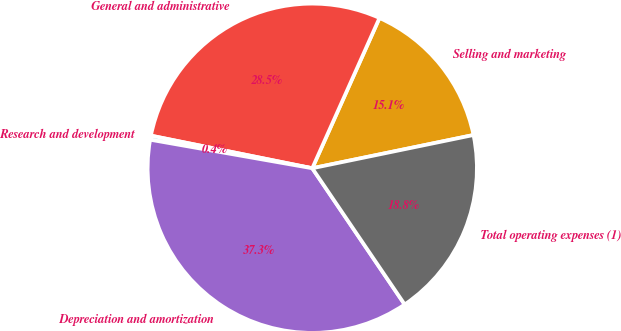Convert chart to OTSL. <chart><loc_0><loc_0><loc_500><loc_500><pie_chart><fcel>Selling and marketing<fcel>General and administrative<fcel>Research and development<fcel>Depreciation and amortization<fcel>Total operating expenses (1)<nl><fcel>15.07%<fcel>28.52%<fcel>0.4%<fcel>37.26%<fcel>18.75%<nl></chart> 